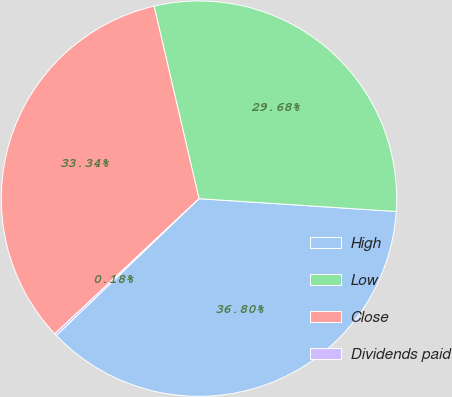<chart> <loc_0><loc_0><loc_500><loc_500><pie_chart><fcel>High<fcel>Low<fcel>Close<fcel>Dividends paid<nl><fcel>36.8%<fcel>29.68%<fcel>33.34%<fcel>0.18%<nl></chart> 